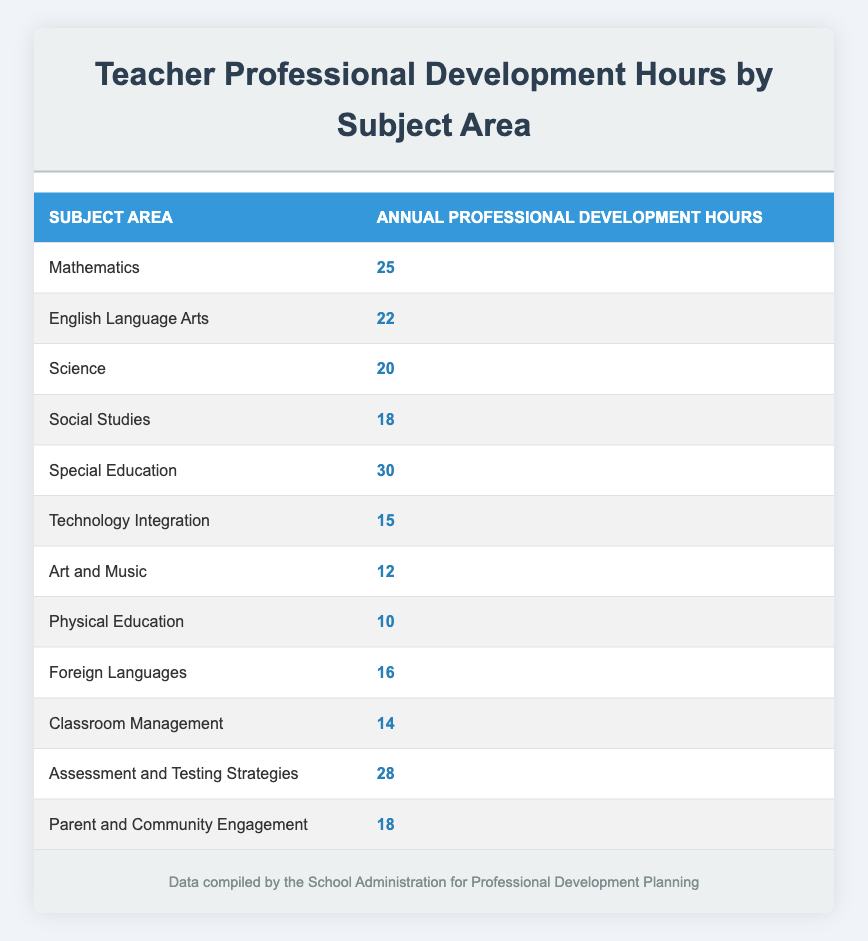What subject area has the highest professional development hours? The subject area with the highest hours can be found by reviewing the "Annual Professional Development Hours" column. The highest value in this column is 30, which corresponds to "Special Education."
Answer: Special Education How many hours of professional development do teachers spend on English Language Arts? The table shows that for English Language Arts, the annual professional development hours are listed as 22.
Answer: 22 What are the total professional development hours for Classroom Management and Technology Integration combined? To find the total, add the professional development hours for both subject areas. Classroom Management has 14 hours and Technology Integration has 15 hours. Therefore, the total is 14 + 15 = 29 hours.
Answer: 29 Is the number of professional development hours for Science greater than that for Physical Education? By checking the table, Science has 20 hours, while Physical Education has only 10 hours. Since 20 is greater than 10, the statement is true.
Answer: Yes What is the average number of professional development hours for the subjects listed? First, sum up all hours: 25 + 22 + 20 + 18 + 30 + 15 + 12 + 10 + 16 + 14 + 28 + 18 =  128. There are 12 subject areas. To find the average, divide the total by the number of subjects: 128 / 12 = approximately 10.67.
Answer: 10.67 What subject areas have fewer than 15 hours of professional development? From the table, the subject areas with fewer than 15 hours are Art and Music (12) and Physical Education (10).
Answer: Art and Music, Physical Education Which subject areas have the same number of professional development hours as Social Studies? The table shows that Social Studies has 18 hours. By checking the other areas, both "Parent and Community Engagement" also has 18 hours, making them the same.
Answer: Parent and Community Engagement How many more hours do teachers spend on Assessment and Testing Strategies compared to Art and Music? The hours for Assessment and Testing Strategies are 28 and for Art and Music are 12. Subtract the two: 28 - 12 = 16.
Answer: 16 How many subjects have more than 20 professional development hours? The subjects with more than 20 hours are Mathematics (25), Special Education (30), and Assessment and Testing Strategies (28). That gives a total of three categories.
Answer: 3 